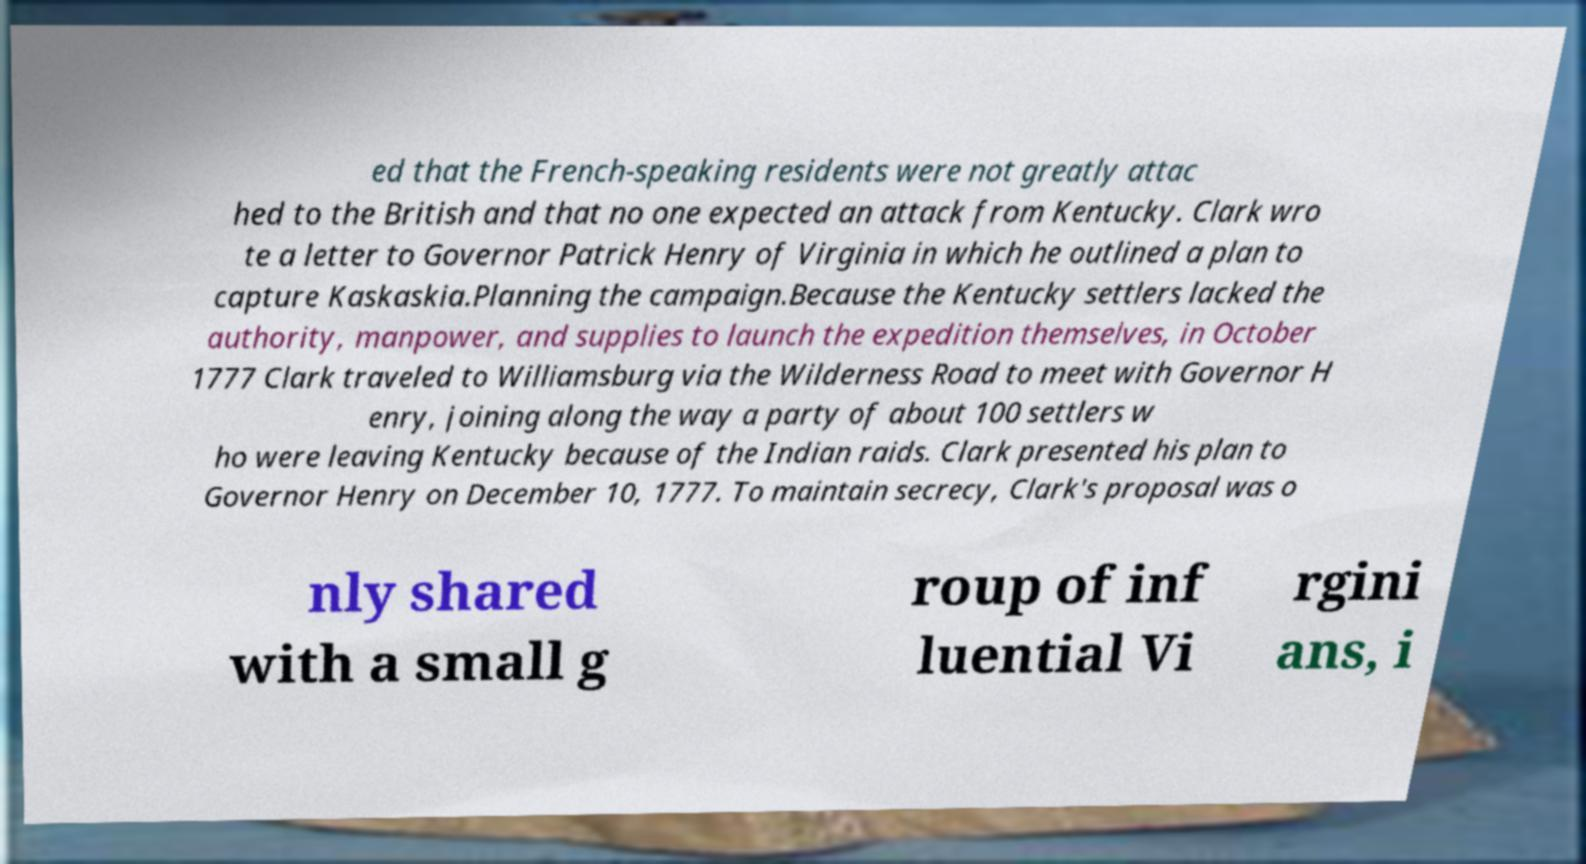Can you read and provide the text displayed in the image?This photo seems to have some interesting text. Can you extract and type it out for me? ed that the French-speaking residents were not greatly attac hed to the British and that no one expected an attack from Kentucky. Clark wro te a letter to Governor Patrick Henry of Virginia in which he outlined a plan to capture Kaskaskia.Planning the campaign.Because the Kentucky settlers lacked the authority, manpower, and supplies to launch the expedition themselves, in October 1777 Clark traveled to Williamsburg via the Wilderness Road to meet with Governor H enry, joining along the way a party of about 100 settlers w ho were leaving Kentucky because of the Indian raids. Clark presented his plan to Governor Henry on December 10, 1777. To maintain secrecy, Clark's proposal was o nly shared with a small g roup of inf luential Vi rgini ans, i 